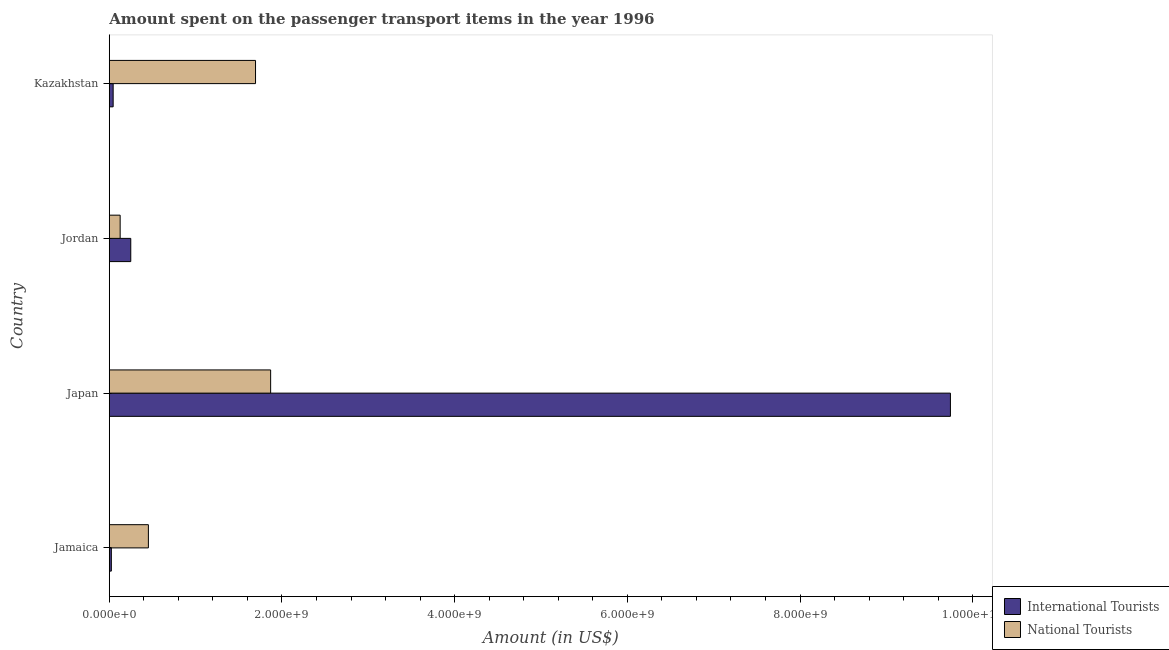How many bars are there on the 1st tick from the top?
Your response must be concise. 2. How many bars are there on the 4th tick from the bottom?
Offer a terse response. 2. What is the label of the 4th group of bars from the top?
Your response must be concise. Jamaica. What is the amount spent on transport items of international tourists in Kazakhstan?
Give a very brief answer. 4.50e+07. Across all countries, what is the maximum amount spent on transport items of international tourists?
Ensure brevity in your answer.  9.74e+09. Across all countries, what is the minimum amount spent on transport items of international tourists?
Provide a succinct answer. 2.40e+07. In which country was the amount spent on transport items of national tourists maximum?
Make the answer very short. Japan. In which country was the amount spent on transport items of international tourists minimum?
Keep it short and to the point. Jamaica. What is the total amount spent on transport items of international tourists in the graph?
Provide a succinct answer. 1.01e+1. What is the difference between the amount spent on transport items of international tourists in Jamaica and that in Japan?
Make the answer very short. -9.72e+09. What is the difference between the amount spent on transport items of international tourists in Kazakhstan and the amount spent on transport items of national tourists in Jamaica?
Offer a very short reply. -4.08e+08. What is the average amount spent on transport items of international tourists per country?
Provide a short and direct response. 2.52e+09. What is the difference between the amount spent on transport items of national tourists and amount spent on transport items of international tourists in Jamaica?
Provide a succinct answer. 4.29e+08. In how many countries, is the amount spent on transport items of international tourists greater than 4400000000 US$?
Provide a short and direct response. 1. What is the ratio of the amount spent on transport items of international tourists in Japan to that in Kazakhstan?
Ensure brevity in your answer.  216.49. What is the difference between the highest and the second highest amount spent on transport items of international tourists?
Make the answer very short. 9.49e+09. What is the difference between the highest and the lowest amount spent on transport items of international tourists?
Your answer should be compact. 9.72e+09. In how many countries, is the amount spent on transport items of national tourists greater than the average amount spent on transport items of national tourists taken over all countries?
Offer a terse response. 2. Is the sum of the amount spent on transport items of international tourists in Jamaica and Jordan greater than the maximum amount spent on transport items of national tourists across all countries?
Your answer should be compact. No. What does the 2nd bar from the top in Japan represents?
Make the answer very short. International Tourists. What does the 2nd bar from the bottom in Jamaica represents?
Your answer should be compact. National Tourists. How many countries are there in the graph?
Ensure brevity in your answer.  4. What is the difference between two consecutive major ticks on the X-axis?
Provide a succinct answer. 2.00e+09. Does the graph contain grids?
Keep it short and to the point. No. What is the title of the graph?
Offer a terse response. Amount spent on the passenger transport items in the year 1996. What is the label or title of the X-axis?
Offer a terse response. Amount (in US$). What is the Amount (in US$) in International Tourists in Jamaica?
Your answer should be very brief. 2.40e+07. What is the Amount (in US$) of National Tourists in Jamaica?
Ensure brevity in your answer.  4.53e+08. What is the Amount (in US$) in International Tourists in Japan?
Your response must be concise. 9.74e+09. What is the Amount (in US$) of National Tourists in Japan?
Ensure brevity in your answer.  1.87e+09. What is the Amount (in US$) in International Tourists in Jordan?
Provide a succinct answer. 2.49e+08. What is the Amount (in US$) of National Tourists in Jordan?
Offer a very short reply. 1.26e+08. What is the Amount (in US$) in International Tourists in Kazakhstan?
Ensure brevity in your answer.  4.50e+07. What is the Amount (in US$) in National Tourists in Kazakhstan?
Your answer should be very brief. 1.69e+09. Across all countries, what is the maximum Amount (in US$) of International Tourists?
Your response must be concise. 9.74e+09. Across all countries, what is the maximum Amount (in US$) of National Tourists?
Provide a short and direct response. 1.87e+09. Across all countries, what is the minimum Amount (in US$) of International Tourists?
Provide a succinct answer. 2.40e+07. Across all countries, what is the minimum Amount (in US$) in National Tourists?
Your answer should be compact. 1.26e+08. What is the total Amount (in US$) of International Tourists in the graph?
Offer a terse response. 1.01e+1. What is the total Amount (in US$) in National Tourists in the graph?
Your answer should be compact. 4.14e+09. What is the difference between the Amount (in US$) in International Tourists in Jamaica and that in Japan?
Your answer should be very brief. -9.72e+09. What is the difference between the Amount (in US$) in National Tourists in Jamaica and that in Japan?
Offer a very short reply. -1.42e+09. What is the difference between the Amount (in US$) of International Tourists in Jamaica and that in Jordan?
Offer a terse response. -2.25e+08. What is the difference between the Amount (in US$) of National Tourists in Jamaica and that in Jordan?
Your answer should be compact. 3.27e+08. What is the difference between the Amount (in US$) of International Tourists in Jamaica and that in Kazakhstan?
Provide a short and direct response. -2.10e+07. What is the difference between the Amount (in US$) of National Tourists in Jamaica and that in Kazakhstan?
Your answer should be very brief. -1.24e+09. What is the difference between the Amount (in US$) of International Tourists in Japan and that in Jordan?
Your answer should be compact. 9.49e+09. What is the difference between the Amount (in US$) in National Tourists in Japan and that in Jordan?
Ensure brevity in your answer.  1.74e+09. What is the difference between the Amount (in US$) in International Tourists in Japan and that in Kazakhstan?
Provide a succinct answer. 9.70e+09. What is the difference between the Amount (in US$) in National Tourists in Japan and that in Kazakhstan?
Offer a terse response. 1.75e+08. What is the difference between the Amount (in US$) of International Tourists in Jordan and that in Kazakhstan?
Your answer should be compact. 2.04e+08. What is the difference between the Amount (in US$) in National Tourists in Jordan and that in Kazakhstan?
Give a very brief answer. -1.57e+09. What is the difference between the Amount (in US$) of International Tourists in Jamaica and the Amount (in US$) of National Tourists in Japan?
Keep it short and to the point. -1.84e+09. What is the difference between the Amount (in US$) in International Tourists in Jamaica and the Amount (in US$) in National Tourists in Jordan?
Keep it short and to the point. -1.02e+08. What is the difference between the Amount (in US$) in International Tourists in Jamaica and the Amount (in US$) in National Tourists in Kazakhstan?
Make the answer very short. -1.67e+09. What is the difference between the Amount (in US$) in International Tourists in Japan and the Amount (in US$) in National Tourists in Jordan?
Your answer should be compact. 9.62e+09. What is the difference between the Amount (in US$) in International Tourists in Japan and the Amount (in US$) in National Tourists in Kazakhstan?
Make the answer very short. 8.05e+09. What is the difference between the Amount (in US$) in International Tourists in Jordan and the Amount (in US$) in National Tourists in Kazakhstan?
Give a very brief answer. -1.44e+09. What is the average Amount (in US$) of International Tourists per country?
Ensure brevity in your answer.  2.52e+09. What is the average Amount (in US$) in National Tourists per country?
Your answer should be compact. 1.04e+09. What is the difference between the Amount (in US$) of International Tourists and Amount (in US$) of National Tourists in Jamaica?
Provide a short and direct response. -4.29e+08. What is the difference between the Amount (in US$) in International Tourists and Amount (in US$) in National Tourists in Japan?
Your answer should be compact. 7.87e+09. What is the difference between the Amount (in US$) in International Tourists and Amount (in US$) in National Tourists in Jordan?
Make the answer very short. 1.23e+08. What is the difference between the Amount (in US$) of International Tourists and Amount (in US$) of National Tourists in Kazakhstan?
Offer a terse response. -1.65e+09. What is the ratio of the Amount (in US$) in International Tourists in Jamaica to that in Japan?
Ensure brevity in your answer.  0. What is the ratio of the Amount (in US$) of National Tourists in Jamaica to that in Japan?
Your response must be concise. 0.24. What is the ratio of the Amount (in US$) in International Tourists in Jamaica to that in Jordan?
Your answer should be compact. 0.1. What is the ratio of the Amount (in US$) in National Tourists in Jamaica to that in Jordan?
Make the answer very short. 3.6. What is the ratio of the Amount (in US$) of International Tourists in Jamaica to that in Kazakhstan?
Provide a succinct answer. 0.53. What is the ratio of the Amount (in US$) of National Tourists in Jamaica to that in Kazakhstan?
Your answer should be compact. 0.27. What is the ratio of the Amount (in US$) of International Tourists in Japan to that in Jordan?
Your answer should be very brief. 39.12. What is the ratio of the Amount (in US$) in National Tourists in Japan to that in Jordan?
Keep it short and to the point. 14.83. What is the ratio of the Amount (in US$) of International Tourists in Japan to that in Kazakhstan?
Provide a succinct answer. 216.49. What is the ratio of the Amount (in US$) in National Tourists in Japan to that in Kazakhstan?
Ensure brevity in your answer.  1.1. What is the ratio of the Amount (in US$) of International Tourists in Jordan to that in Kazakhstan?
Your answer should be compact. 5.53. What is the ratio of the Amount (in US$) of National Tourists in Jordan to that in Kazakhstan?
Offer a very short reply. 0.07. What is the difference between the highest and the second highest Amount (in US$) of International Tourists?
Offer a terse response. 9.49e+09. What is the difference between the highest and the second highest Amount (in US$) in National Tourists?
Provide a short and direct response. 1.75e+08. What is the difference between the highest and the lowest Amount (in US$) of International Tourists?
Provide a short and direct response. 9.72e+09. What is the difference between the highest and the lowest Amount (in US$) of National Tourists?
Ensure brevity in your answer.  1.74e+09. 